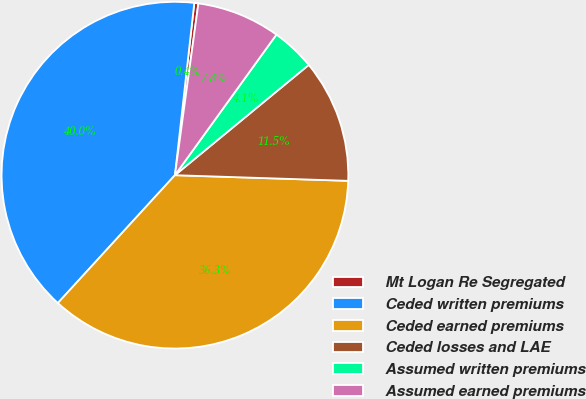Convert chart to OTSL. <chart><loc_0><loc_0><loc_500><loc_500><pie_chart><fcel>Mt Logan Re Segregated<fcel>Ceded written premiums<fcel>Ceded earned premiums<fcel>Ceded losses and LAE<fcel>Assumed written premiums<fcel>Assumed earned premiums<nl><fcel>0.38%<fcel>39.98%<fcel>36.28%<fcel>11.49%<fcel>4.08%<fcel>7.79%<nl></chart> 